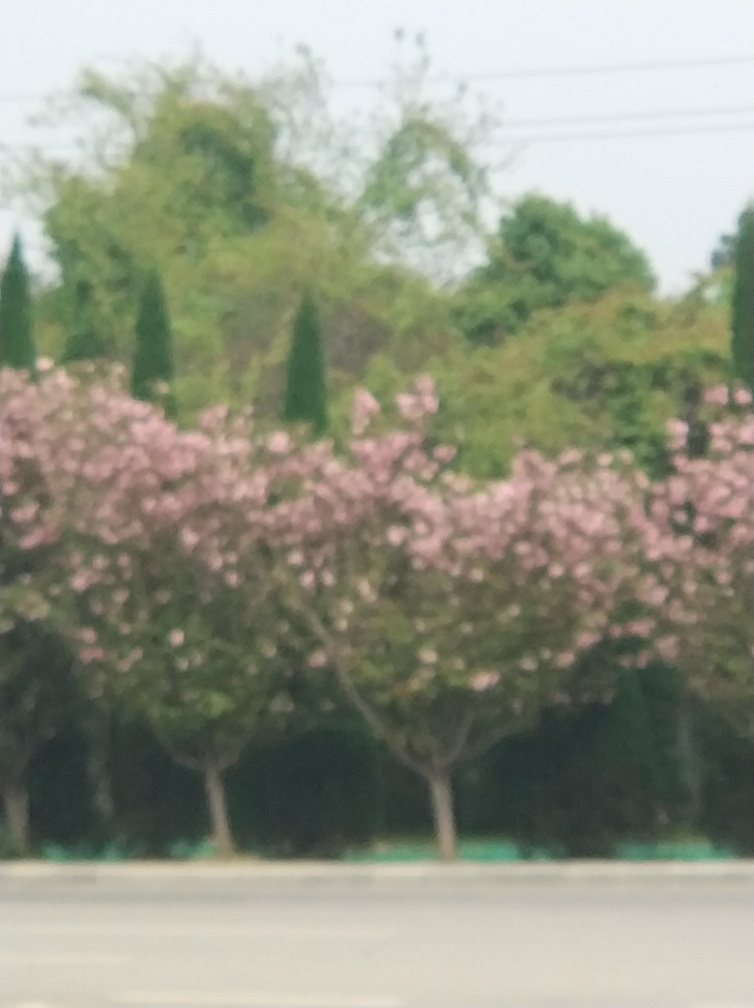What time of year do you think this photo was taken? Considering the lush, full blossoms on the trees, I would infer that this photo was likely taken in spring, which is the typical blooming season for many flowering tree species, including those that closely resemble cherry blossoms. 